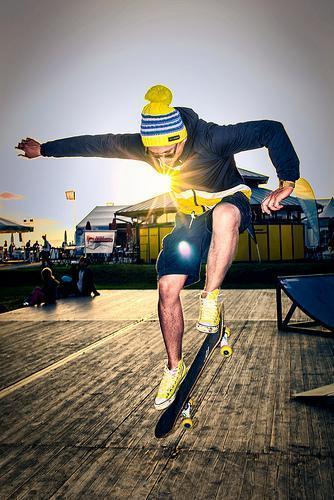How many people in photo?
Give a very brief answer. 1. 